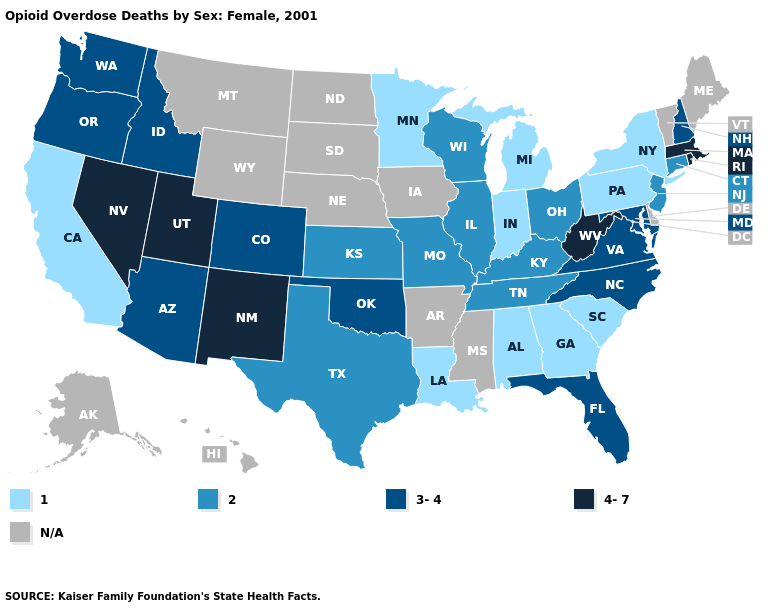What is the value of Delaware?
Be succinct. N/A. Among the states that border Missouri , does Oklahoma have the highest value?
Keep it brief. Yes. Which states have the highest value in the USA?
Quick response, please. Massachusetts, Nevada, New Mexico, Rhode Island, Utah, West Virginia. Among the states that border Wisconsin , which have the lowest value?
Short answer required. Michigan, Minnesota. Which states have the lowest value in the West?
Concise answer only. California. Name the states that have a value in the range N/A?
Give a very brief answer. Alaska, Arkansas, Delaware, Hawaii, Iowa, Maine, Mississippi, Montana, Nebraska, North Dakota, South Dakota, Vermont, Wyoming. Which states have the highest value in the USA?
Short answer required. Massachusetts, Nevada, New Mexico, Rhode Island, Utah, West Virginia. Does Michigan have the lowest value in the USA?
Answer briefly. Yes. Name the states that have a value in the range N/A?
Be succinct. Alaska, Arkansas, Delaware, Hawaii, Iowa, Maine, Mississippi, Montana, Nebraska, North Dakota, South Dakota, Vermont, Wyoming. What is the value of Texas?
Keep it brief. 2. What is the lowest value in the MidWest?
Short answer required. 1. What is the value of Nebraska?
Keep it brief. N/A. 